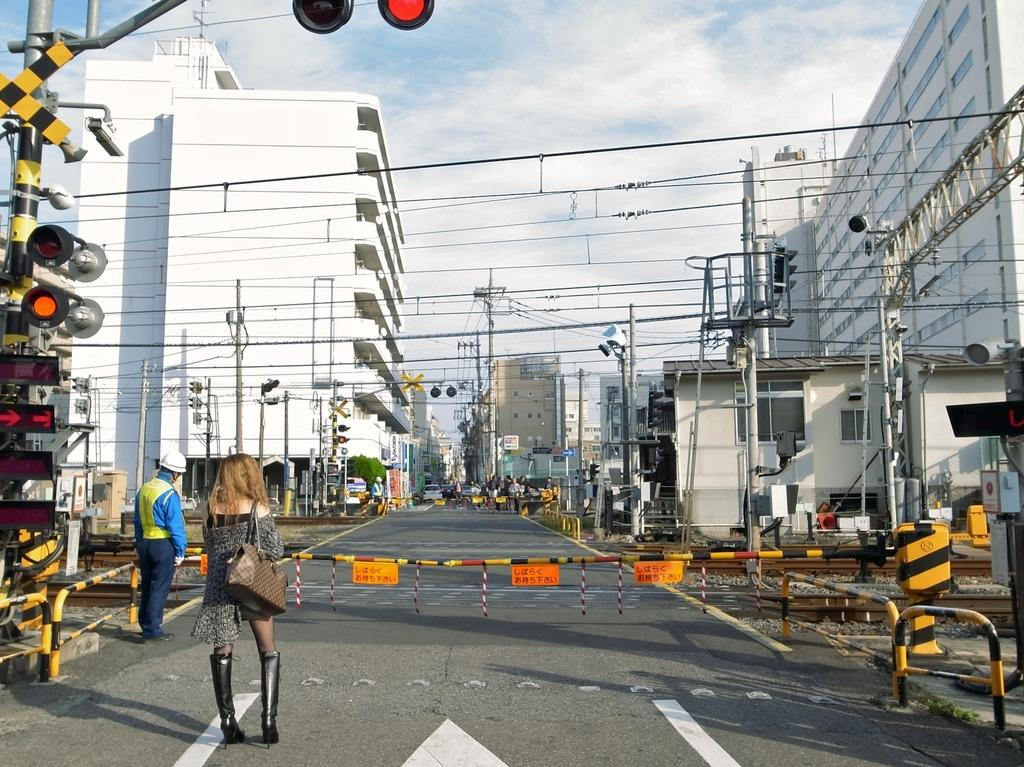What are the people in the image doing? The people in the image are standing on the road. What structures can be seen in the image? There are buildings, an arch, and a railway gate visible in the image. What type of transportation infrastructure is present in the image? A railway track is visible in the image. What safety feature is present at the railway track? A railway gate is present in the image. What else is visible in the image? Traffic lights, current polls, and a box are present in the image. What can be seen in the sky in the image? The sky is visible in the image. What type of vessel is being used to help the people cross the road in the image? There is no vessel present in the image, and the people are standing on the road without any assistance. What day of the week is it in the image? The day of the week is not mentioned or visible in the image. 